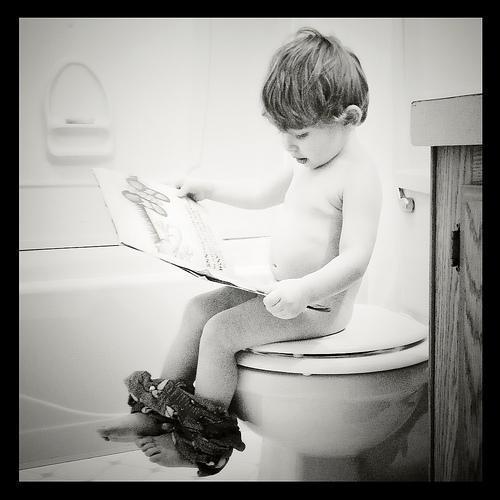How many toilets?
Give a very brief answer. 1. 